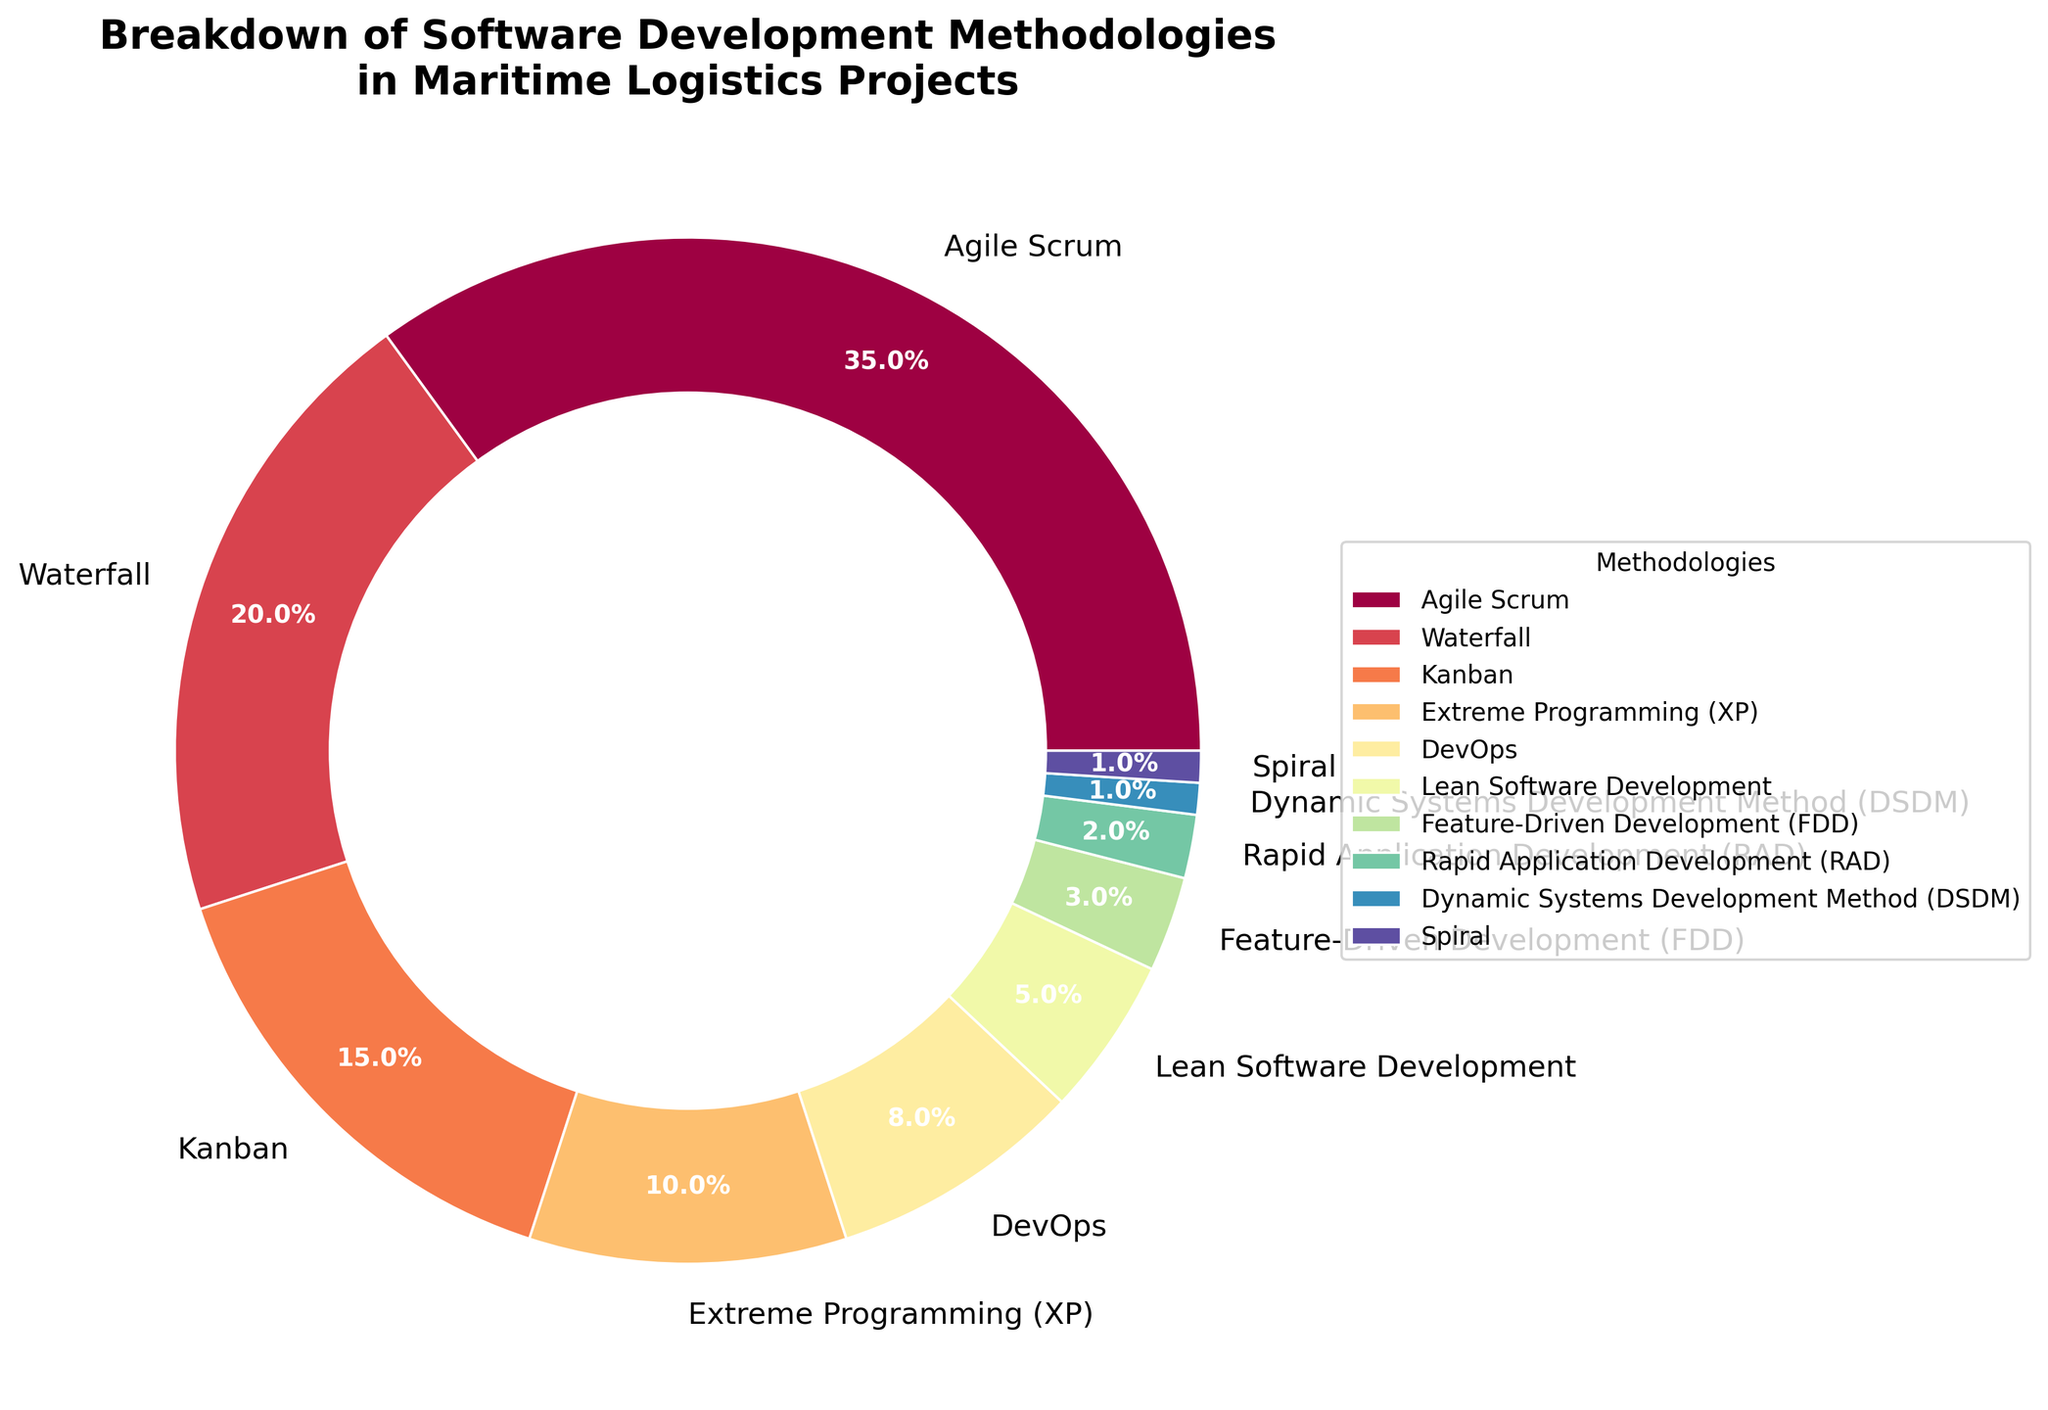What's the most commonly used software development methodology in maritime logistics projects? The figure shows a pie chart with different methodologies and their corresponding percentages. By checking the largest wedge, we see that "Agile Scrum" represents 35%, which is the highest percentage.
Answer: Agile Scrum What percentage of projects use either Agile Scrum or Waterfall methodologies? To find the total percentage of projects using either Agile Scrum or Waterfall, we add their individual percentages: 35% (Agile Scrum) + 20% (Waterfall) = 55%.
Answer: 55% Which methodology has a smaller percentage, Kanban or DevOps? By comparing the wedges, Kanban represents 15%, whereas DevOps represents 8%. Thus, DevOps has a smaller percentage.
Answer: DevOps What is the combined percentage of the three least common methodologies? The least common methodologies as shown in the figure are DSDM (1%), Spiral (1%), and RAD (2%). Adding these gives us 1% + 1% + 2% = 4%.
Answer: 4% How does the percentage of Kanban compare to the combined percentage of Lean Software Development and Extreme Programming (XP)? Kanban has a percentage of 15%. Lean Software Development and Extreme Programming (XP) have percentages of 5% and 10%, respectively. Adding these gives 5% + 10% = 15%. Therefore, Kanban's percentage is equal to the combined percentage of Lean Software Development and Extreme Programming (XP).
Answer: Equal to What's the total percentage of projects that use methodologies other than Agile Scrum and Waterfall? Agile Scrum and Waterfall together account for 35% + 20% = 55%. The total percentage of all methodologies is 100%, so the percentage of projects using methodologies other than Agile Scrum and Waterfall is 100% - 55% = 45%.
Answer: 45% If we combine the percentages of Agile Scrum, Waterfall, and Kanban, what is the resultant value? Agile Scrum represents 35%, Waterfall 20%, and Kanban 15%. Adding these percentages gives 35% + 20% + 15% = 70%.
Answer: 70% Is the percentage of projects using Extreme Programming (XP) greater than or equal to the percentage using Lean Software Development? By looking at the figure, Extreme Programming (XP) accounts for 10%, and Lean Software Development accounts for 5%, so 10% is greater than 5%.
Answer: Greater than How does the percentage of projects using Feature-Driven Development (FDD) compare to those using Rapid Application Development (RAD)? FDD accounts for 3% and RAD 2%. Thus, FDD has a higher percentage than RAD.
Answer: Higher What percentage of projects use methodologies with a percentage below 5%? The methodologies below 5% include Lean Software Development (5%), Feature-Driven Development (3%), Rapid Application Development (2%), DSDM (1%), and Spiral (1%). Adding these percentages gives 5% + 3% + 2% + 1% + 1% = 12%.
Answer: 12% 